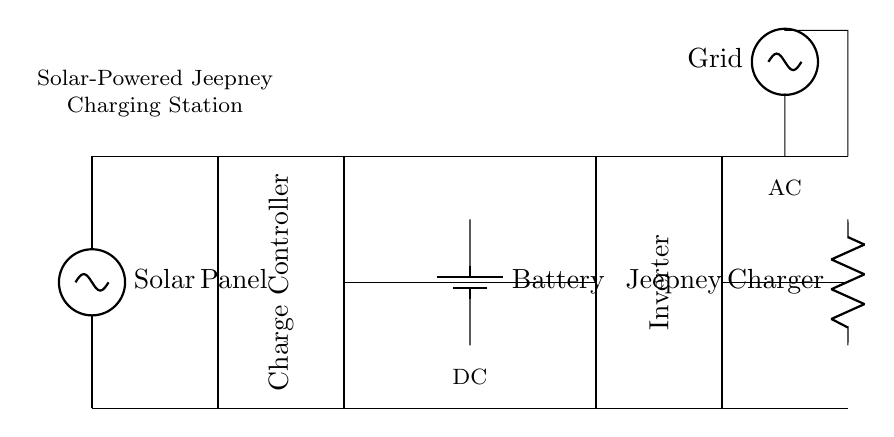What is the primary energy source for this circuit? The primary energy source is the solar panel, which converts sunlight into electrical energy for the circuit.
Answer: Solar panel What component regulates the charging of the battery? The battery is regulated by the charge controller, which ensures that the battery receives the correct voltage and current for safe charging.
Answer: Charge controller How many major components are in this circuit? There are five major components: Solar Panel, Charge Controller, Battery, Inverter, and Jeepney Charger.
Answer: Five What type of load is connected at the output? The load connected at the output is the jeepney charger, which is responsible for charging the electric jeepney.
Answer: Jeepney charger Why is an inverter included in this circuit? The inverter is included to convert the direct current (DC) from the battery into alternating current (AC) suitable for the jeepney charger and grid connection.
Answer: To convert DC to AC What is the purpose of the grid connection in this circuit? The grid connection provides an alternative power source for the system, allowing the charger to operate even when solar power is insufficient.
Answer: Alternative power source Which component stores the energy generated by the solar panel? The energy generated by the solar panel is stored in the battery, which provides power when the solar energy is not actively generated.
Answer: Battery 